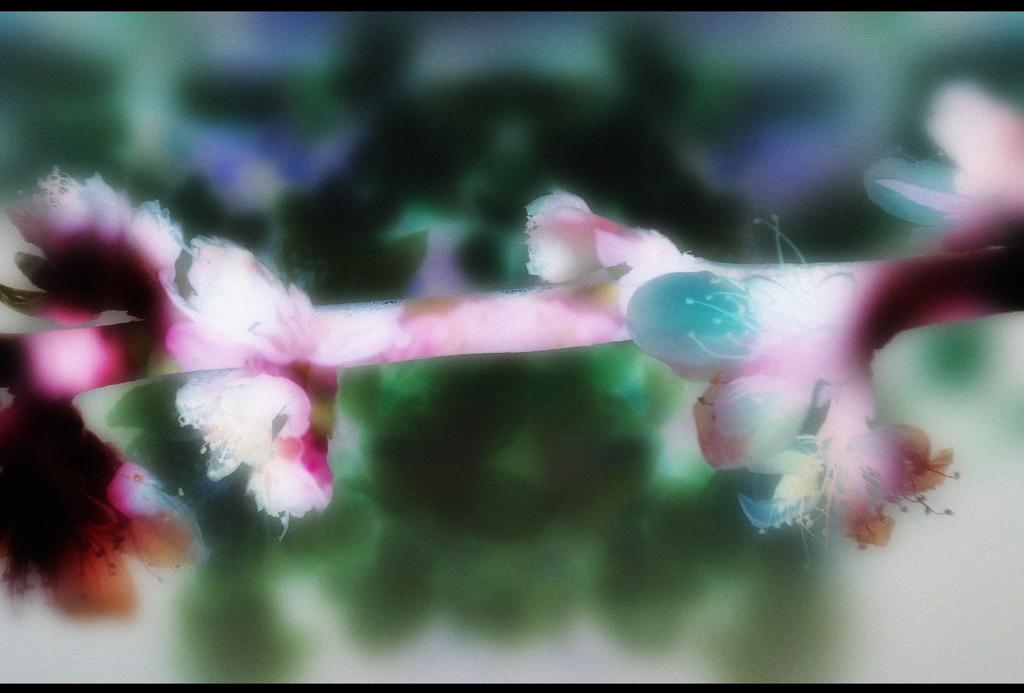What is the main subject of the image? The main subject of the image is a flower. What is the dominant color of the flower? The flower has a pink color. Are there any other colors present in the flower? Yes, the flower has other colors besides pink. What type of substance is being poured into the shoe in the image? There is no shoe or substance present in the image; it only features a flower with multiple colors. 